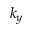Convert formula to latex. <formula><loc_0><loc_0><loc_500><loc_500>k _ { y }</formula> 